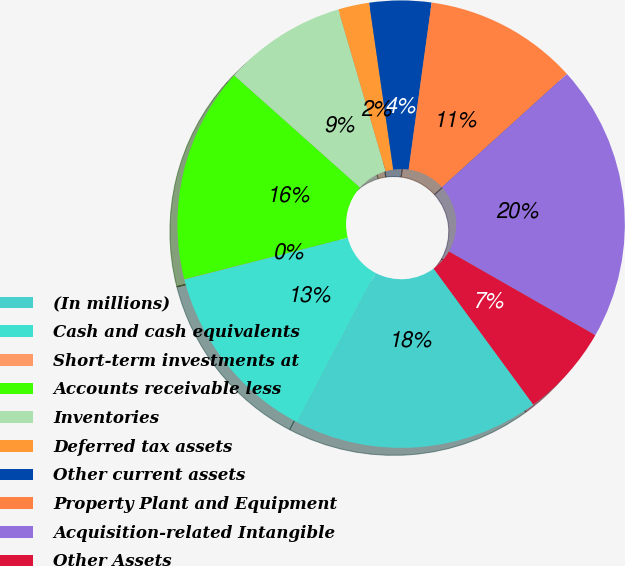<chart> <loc_0><loc_0><loc_500><loc_500><pie_chart><fcel>(In millions)<fcel>Cash and cash equivalents<fcel>Short-term investments at<fcel>Accounts receivable less<fcel>Inventories<fcel>Deferred tax assets<fcel>Other current assets<fcel>Property Plant and Equipment<fcel>Acquisition-related Intangible<fcel>Other Assets<nl><fcel>17.76%<fcel>13.33%<fcel>0.02%<fcel>15.54%<fcel>8.89%<fcel>2.24%<fcel>4.46%<fcel>11.11%<fcel>19.98%<fcel>6.67%<nl></chart> 